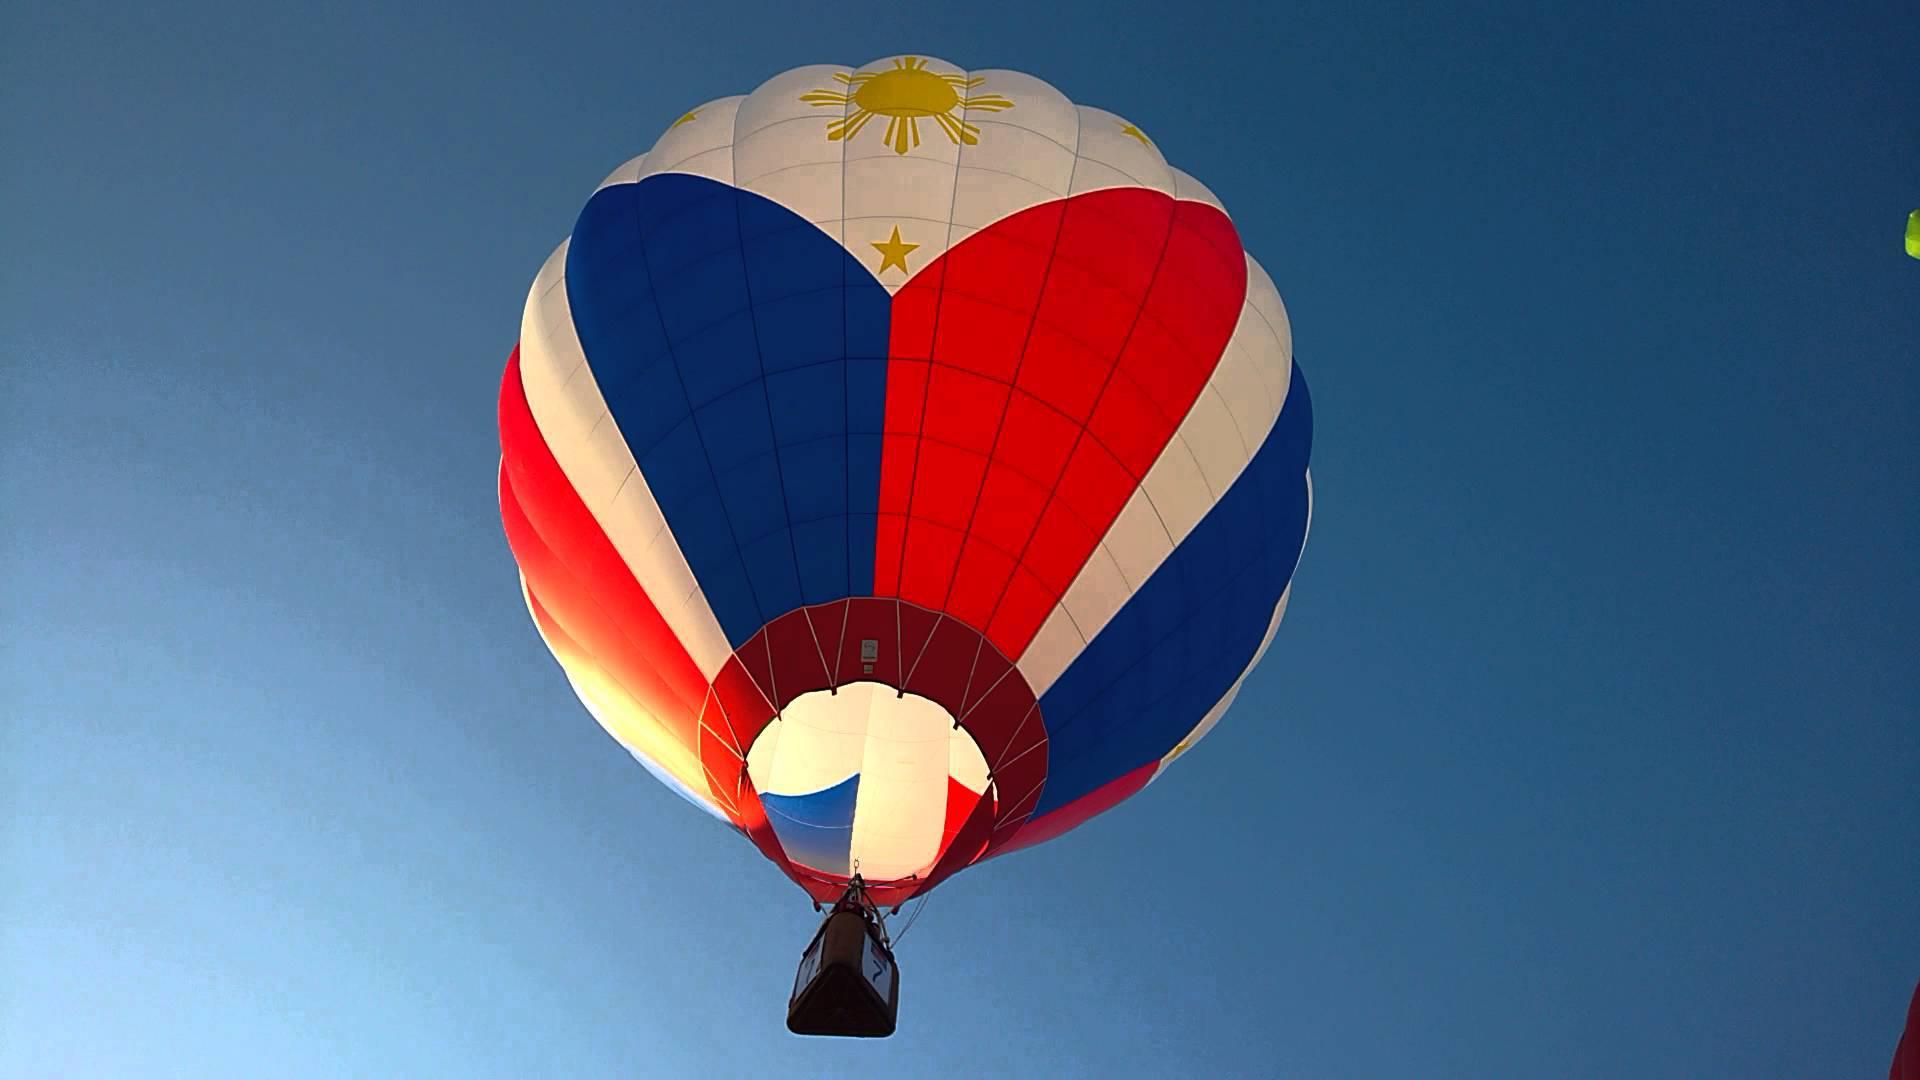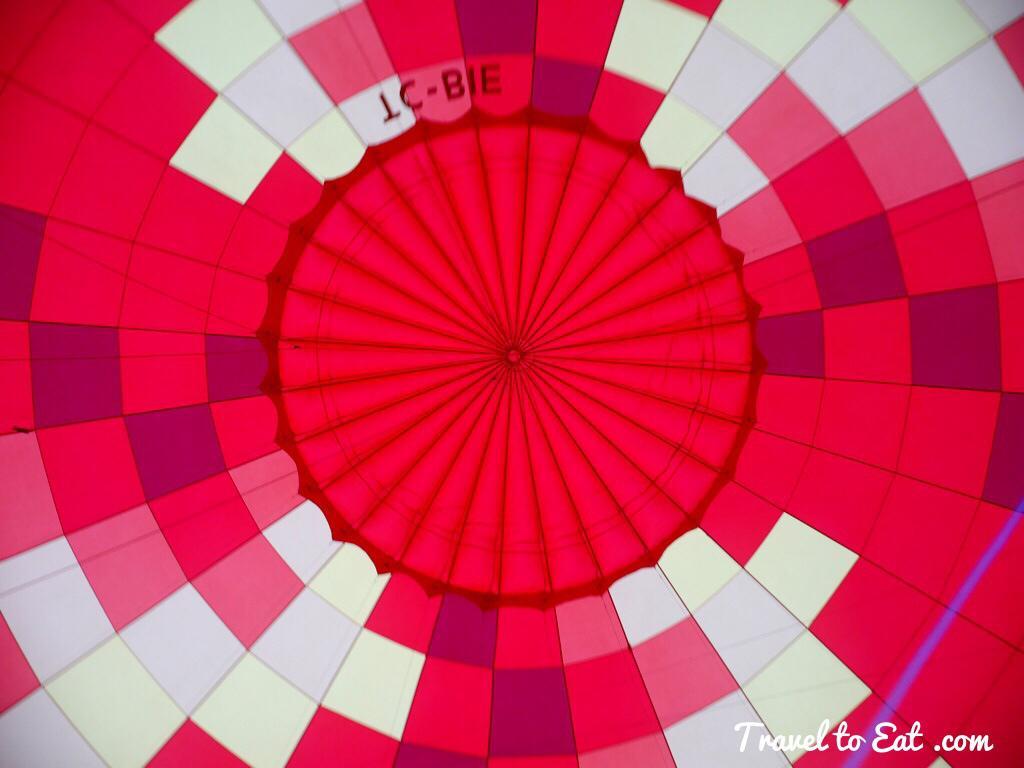The first image is the image on the left, the second image is the image on the right. Assess this claim about the two images: "A blue circle design is at the top of the balloon on the right.". Correct or not? Answer yes or no. No. The first image is the image on the left, the second image is the image on the right. For the images displayed, is the sentence "The fabric of the hot-air balloon in the left image features at least three colors." factually correct? Answer yes or no. Yes. 